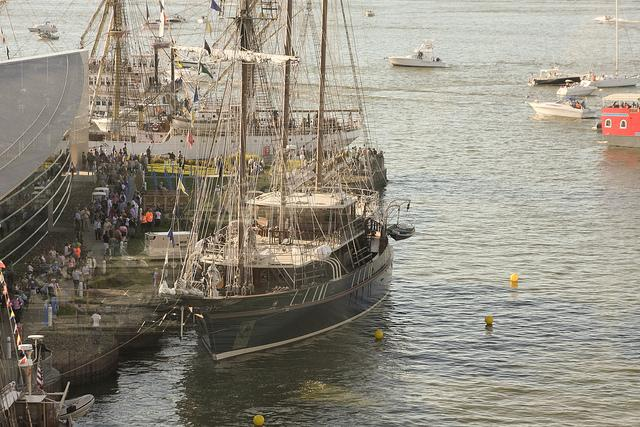How many sail posts are on the back of this historic sailing ship? Please explain your reasoning. three. One sail post is in between two others. 